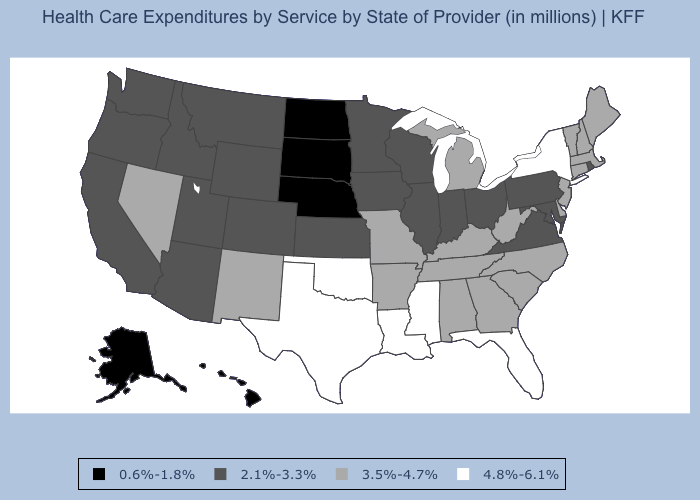Name the states that have a value in the range 4.8%-6.1%?
Be succinct. Florida, Louisiana, Mississippi, New York, Oklahoma, Texas. Which states have the highest value in the USA?
Give a very brief answer. Florida, Louisiana, Mississippi, New York, Oklahoma, Texas. Does Arkansas have the same value as Georgia?
Keep it brief. Yes. Name the states that have a value in the range 3.5%-4.7%?
Keep it brief. Alabama, Arkansas, Connecticut, Delaware, Georgia, Kentucky, Maine, Massachusetts, Michigan, Missouri, Nevada, New Hampshire, New Jersey, New Mexico, North Carolina, South Carolina, Tennessee, Vermont, West Virginia. What is the value of Wyoming?
Concise answer only. 2.1%-3.3%. Is the legend a continuous bar?
Write a very short answer. No. What is the highest value in states that border Colorado?
Write a very short answer. 4.8%-6.1%. Does the first symbol in the legend represent the smallest category?
Quick response, please. Yes. Name the states that have a value in the range 3.5%-4.7%?
Give a very brief answer. Alabama, Arkansas, Connecticut, Delaware, Georgia, Kentucky, Maine, Massachusetts, Michigan, Missouri, Nevada, New Hampshire, New Jersey, New Mexico, North Carolina, South Carolina, Tennessee, Vermont, West Virginia. What is the value of South Carolina?
Short answer required. 3.5%-4.7%. What is the value of Maryland?
Give a very brief answer. 2.1%-3.3%. What is the value of New York?
Answer briefly. 4.8%-6.1%. Does the first symbol in the legend represent the smallest category?
Write a very short answer. Yes. What is the highest value in states that border Indiana?
Short answer required. 3.5%-4.7%. What is the highest value in states that border Washington?
Concise answer only. 2.1%-3.3%. 